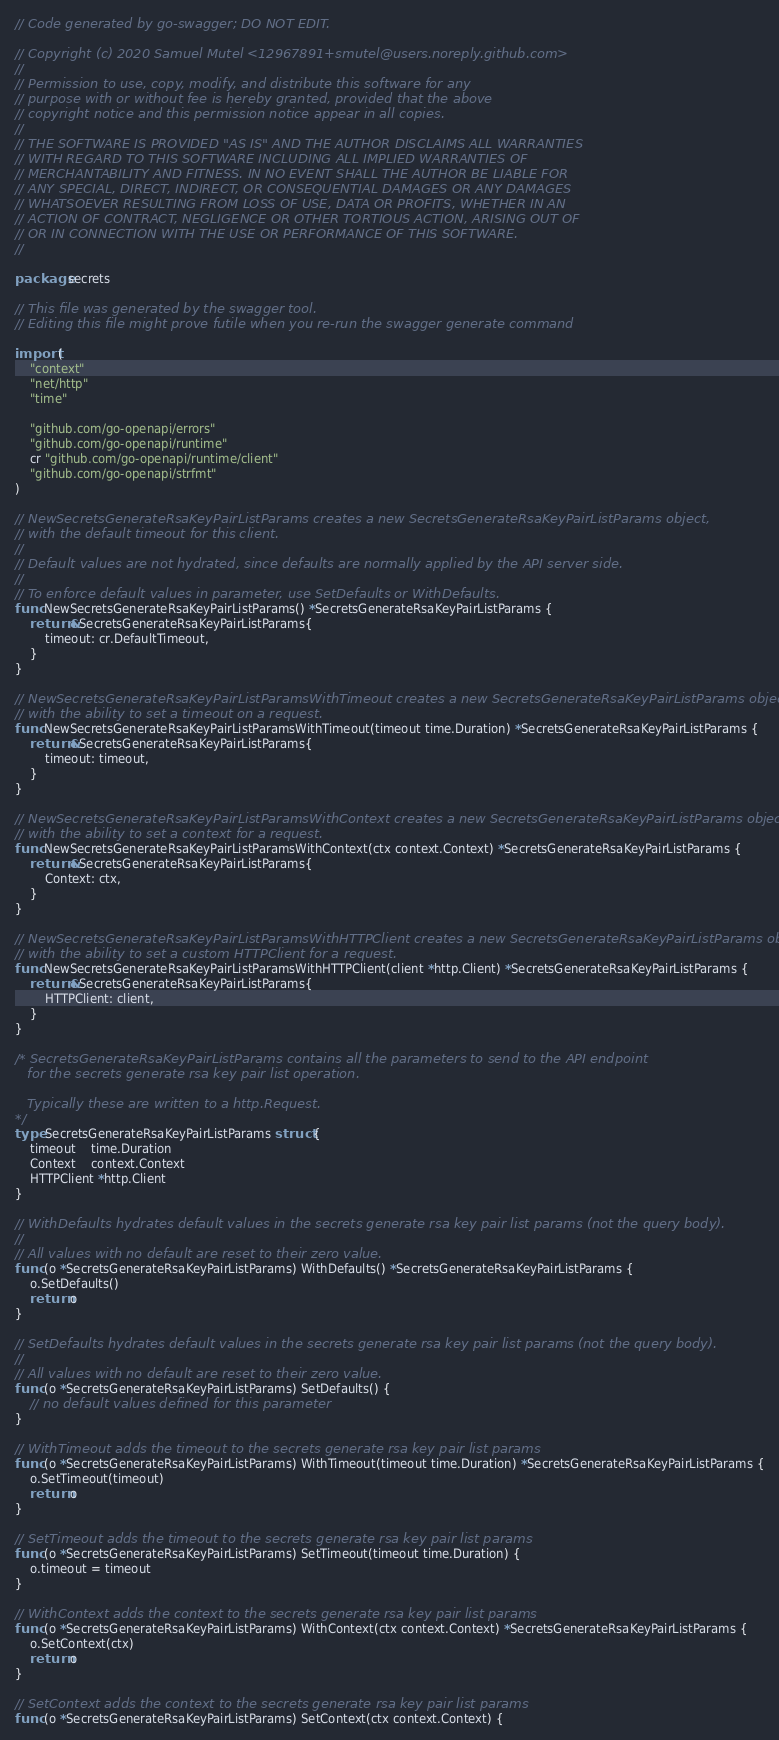<code> <loc_0><loc_0><loc_500><loc_500><_Go_>// Code generated by go-swagger; DO NOT EDIT.

// Copyright (c) 2020 Samuel Mutel <12967891+smutel@users.noreply.github.com>
//
// Permission to use, copy, modify, and distribute this software for any
// purpose with or without fee is hereby granted, provided that the above
// copyright notice and this permission notice appear in all copies.
//
// THE SOFTWARE IS PROVIDED "AS IS" AND THE AUTHOR DISCLAIMS ALL WARRANTIES
// WITH REGARD TO THIS SOFTWARE INCLUDING ALL IMPLIED WARRANTIES OF
// MERCHANTABILITY AND FITNESS. IN NO EVENT SHALL THE AUTHOR BE LIABLE FOR
// ANY SPECIAL, DIRECT, INDIRECT, OR CONSEQUENTIAL DAMAGES OR ANY DAMAGES
// WHATSOEVER RESULTING FROM LOSS OF USE, DATA OR PROFITS, WHETHER IN AN
// ACTION OF CONTRACT, NEGLIGENCE OR OTHER TORTIOUS ACTION, ARISING OUT OF
// OR IN CONNECTION WITH THE USE OR PERFORMANCE OF THIS SOFTWARE.
//

package secrets

// This file was generated by the swagger tool.
// Editing this file might prove futile when you re-run the swagger generate command

import (
	"context"
	"net/http"
	"time"

	"github.com/go-openapi/errors"
	"github.com/go-openapi/runtime"
	cr "github.com/go-openapi/runtime/client"
	"github.com/go-openapi/strfmt"
)

// NewSecretsGenerateRsaKeyPairListParams creates a new SecretsGenerateRsaKeyPairListParams object,
// with the default timeout for this client.
//
// Default values are not hydrated, since defaults are normally applied by the API server side.
//
// To enforce default values in parameter, use SetDefaults or WithDefaults.
func NewSecretsGenerateRsaKeyPairListParams() *SecretsGenerateRsaKeyPairListParams {
	return &SecretsGenerateRsaKeyPairListParams{
		timeout: cr.DefaultTimeout,
	}
}

// NewSecretsGenerateRsaKeyPairListParamsWithTimeout creates a new SecretsGenerateRsaKeyPairListParams object
// with the ability to set a timeout on a request.
func NewSecretsGenerateRsaKeyPairListParamsWithTimeout(timeout time.Duration) *SecretsGenerateRsaKeyPairListParams {
	return &SecretsGenerateRsaKeyPairListParams{
		timeout: timeout,
	}
}

// NewSecretsGenerateRsaKeyPairListParamsWithContext creates a new SecretsGenerateRsaKeyPairListParams object
// with the ability to set a context for a request.
func NewSecretsGenerateRsaKeyPairListParamsWithContext(ctx context.Context) *SecretsGenerateRsaKeyPairListParams {
	return &SecretsGenerateRsaKeyPairListParams{
		Context: ctx,
	}
}

// NewSecretsGenerateRsaKeyPairListParamsWithHTTPClient creates a new SecretsGenerateRsaKeyPairListParams object
// with the ability to set a custom HTTPClient for a request.
func NewSecretsGenerateRsaKeyPairListParamsWithHTTPClient(client *http.Client) *SecretsGenerateRsaKeyPairListParams {
	return &SecretsGenerateRsaKeyPairListParams{
		HTTPClient: client,
	}
}

/* SecretsGenerateRsaKeyPairListParams contains all the parameters to send to the API endpoint
   for the secrets generate rsa key pair list operation.

   Typically these are written to a http.Request.
*/
type SecretsGenerateRsaKeyPairListParams struct {
	timeout    time.Duration
	Context    context.Context
	HTTPClient *http.Client
}

// WithDefaults hydrates default values in the secrets generate rsa key pair list params (not the query body).
//
// All values with no default are reset to their zero value.
func (o *SecretsGenerateRsaKeyPairListParams) WithDefaults() *SecretsGenerateRsaKeyPairListParams {
	o.SetDefaults()
	return o
}

// SetDefaults hydrates default values in the secrets generate rsa key pair list params (not the query body).
//
// All values with no default are reset to their zero value.
func (o *SecretsGenerateRsaKeyPairListParams) SetDefaults() {
	// no default values defined for this parameter
}

// WithTimeout adds the timeout to the secrets generate rsa key pair list params
func (o *SecretsGenerateRsaKeyPairListParams) WithTimeout(timeout time.Duration) *SecretsGenerateRsaKeyPairListParams {
	o.SetTimeout(timeout)
	return o
}

// SetTimeout adds the timeout to the secrets generate rsa key pair list params
func (o *SecretsGenerateRsaKeyPairListParams) SetTimeout(timeout time.Duration) {
	o.timeout = timeout
}

// WithContext adds the context to the secrets generate rsa key pair list params
func (o *SecretsGenerateRsaKeyPairListParams) WithContext(ctx context.Context) *SecretsGenerateRsaKeyPairListParams {
	o.SetContext(ctx)
	return o
}

// SetContext adds the context to the secrets generate rsa key pair list params
func (o *SecretsGenerateRsaKeyPairListParams) SetContext(ctx context.Context) {</code> 